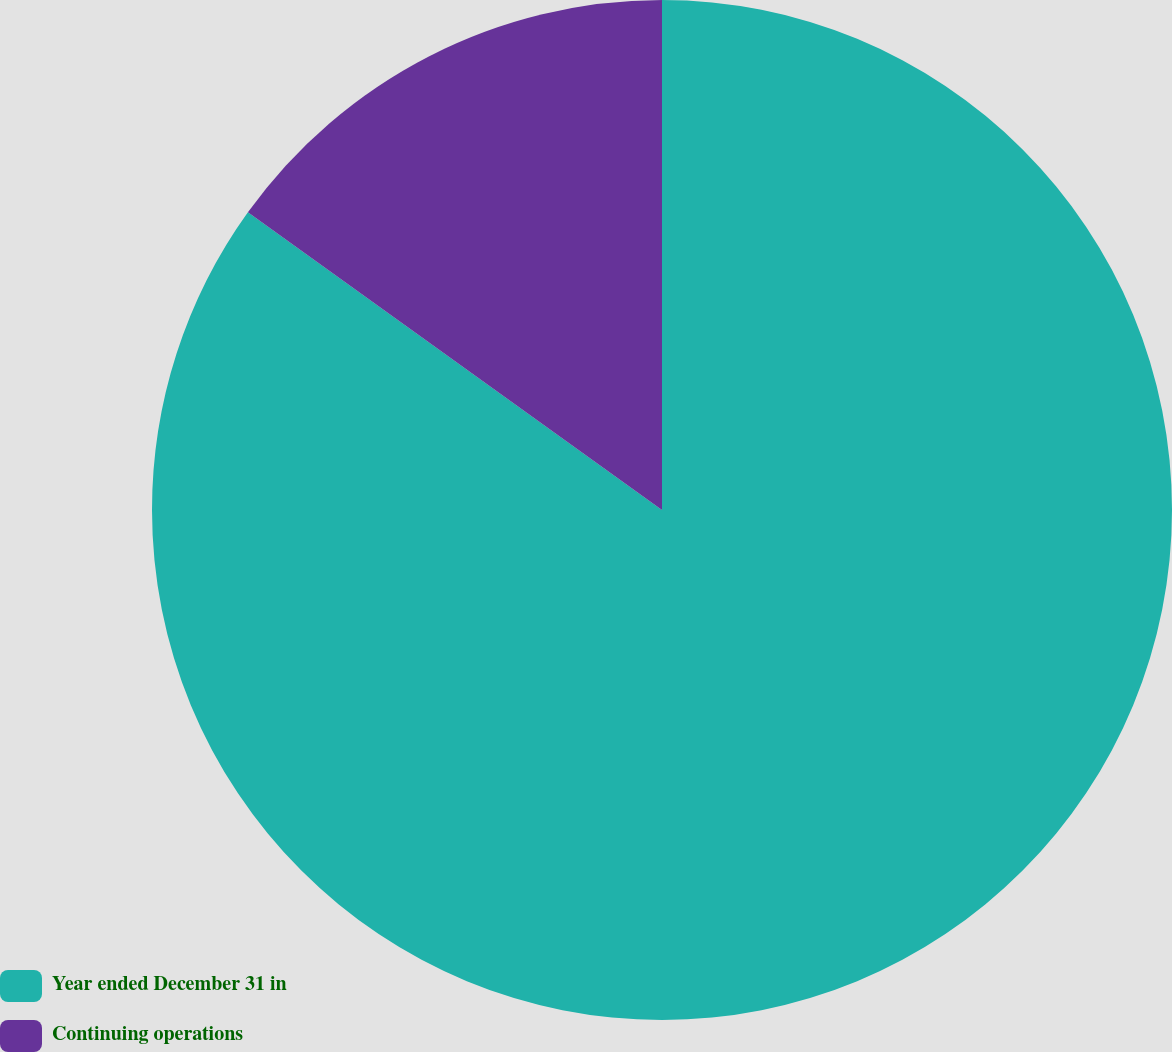Convert chart. <chart><loc_0><loc_0><loc_500><loc_500><pie_chart><fcel>Year ended December 31 in<fcel>Continuing operations<nl><fcel>84.92%<fcel>15.08%<nl></chart> 